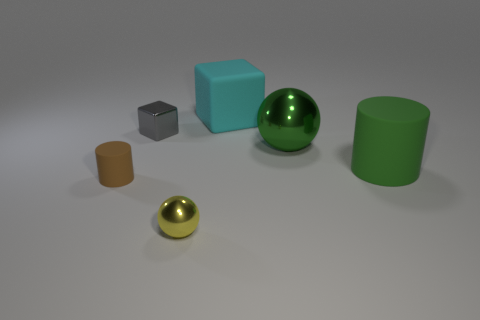Add 1 green cubes. How many objects exist? 7 Subtract all spheres. How many objects are left? 4 Add 2 large brown metal objects. How many large brown metal objects exist? 2 Subtract 0 brown spheres. How many objects are left? 6 Subtract all green cylinders. Subtract all brown matte cylinders. How many objects are left? 4 Add 6 spheres. How many spheres are left? 8 